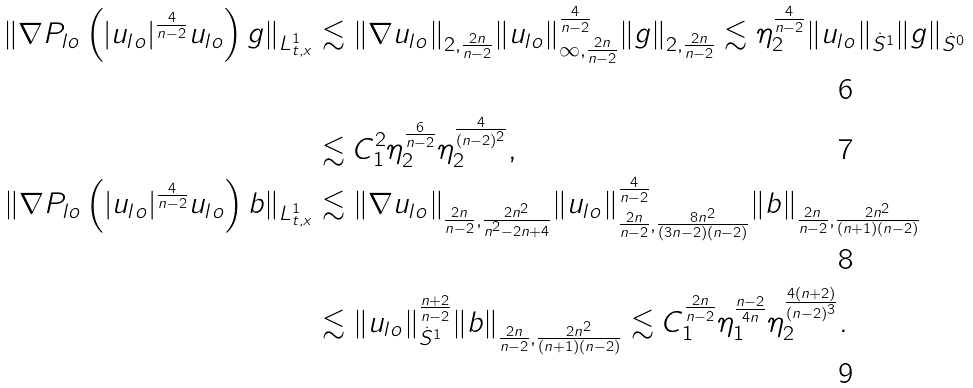Convert formula to latex. <formula><loc_0><loc_0><loc_500><loc_500>\| \nabla P _ { l o } \left ( | u _ { l o } | ^ { \frac { 4 } { n - 2 } } u _ { l o } \right ) g \| _ { L _ { t , x } ^ { 1 } } & \lesssim \| \nabla u _ { l o } \| _ { 2 , \frac { 2 n } { n - 2 } } \| u _ { l o } \| _ { \infty , \frac { 2 n } { n - 2 } } ^ { \frac { 4 } { n - 2 } } \| g \| _ { 2 , \frac { 2 n } { n - 2 } } \lesssim \eta _ { 2 } ^ { \frac { 4 } { n - 2 } } \| u _ { l o } \| _ { \dot { S } ^ { 1 } } \| g \| _ { \dot { S } ^ { 0 } } \\ & \lesssim C _ { 1 } ^ { 2 } \eta _ { 2 } ^ { \frac { 6 } { n - 2 } } \eta _ { 2 } ^ { \frac { 4 } { ( n - 2 ) ^ { 2 } } } , \\ \| \nabla P _ { l o } \left ( | u _ { l o } | ^ { \frac { 4 } { n - 2 } } u _ { l o } \right ) b \| _ { L _ { t , x } ^ { 1 } } & \lesssim \| \nabla u _ { l o } \| _ { \frac { 2 n } { n - 2 } , \frac { 2 n ^ { 2 } } { n ^ { 2 } - 2 n + 4 } } \| u _ { l o } \| _ { \frac { 2 n } { n - 2 } , \frac { 8 n ^ { 2 } } { ( 3 n - 2 ) ( n - 2 ) } } ^ { \frac { 4 } { n - 2 } } \| b \| _ { \frac { 2 n } { n - 2 } , \frac { 2 n ^ { 2 } } { ( n + 1 ) ( n - 2 ) } } \\ & \lesssim \| u _ { l o } \| _ { \dot { S } ^ { 1 } } ^ { \frac { n + 2 } { n - 2 } } \| b \| _ { \frac { 2 n } { n - 2 } , \frac { 2 n ^ { 2 } } { ( n + 1 ) ( n - 2 ) } } \lesssim C _ { 1 } ^ { \frac { 2 n } { n - 2 } } \eta _ { 1 } ^ { \frac { n - 2 } { 4 n } } \eta _ { 2 } ^ { \frac { 4 ( n + 2 ) } { ( n - 2 ) ^ { 3 } } } .</formula> 